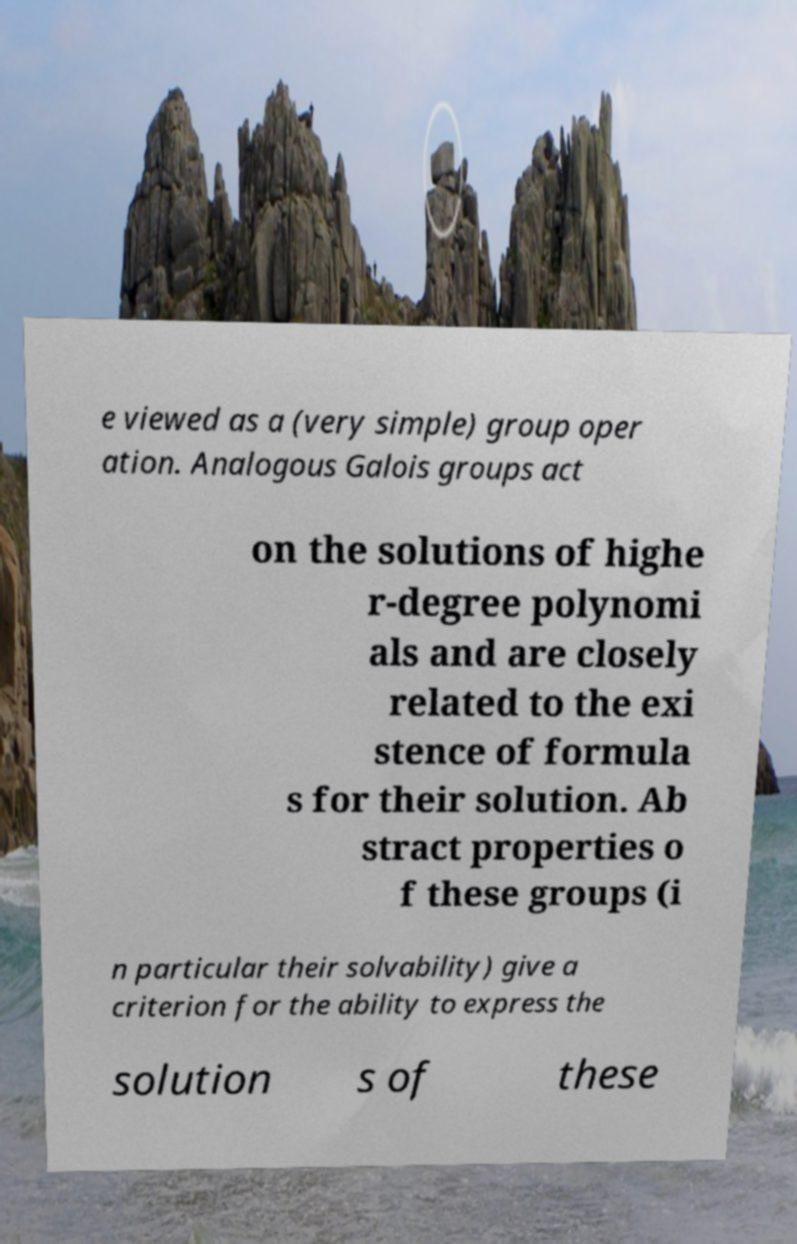Please read and relay the text visible in this image. What does it say? e viewed as a (very simple) group oper ation. Analogous Galois groups act on the solutions of highe r-degree polynomi als and are closely related to the exi stence of formula s for their solution. Ab stract properties o f these groups (i n particular their solvability) give a criterion for the ability to express the solution s of these 